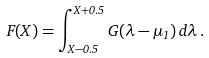Convert formula to latex. <formula><loc_0><loc_0><loc_500><loc_500>F ( X ) = \int _ { X - 0 . 5 } ^ { X + 0 . 5 } G ( \lambda - \mu _ { 1 } ) \, d \lambda \, .</formula> 